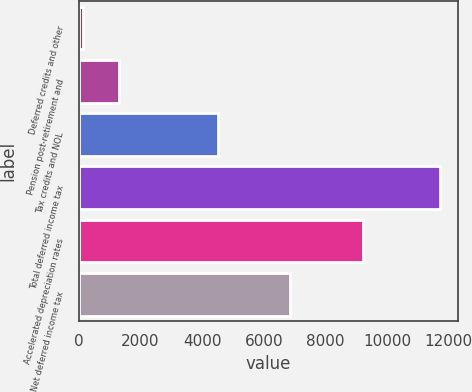<chart> <loc_0><loc_0><loc_500><loc_500><bar_chart><fcel>Deferred credits and other<fcel>Pension post-retirement and<fcel>Tax credits and NOL<fcel>Total deferred income tax<fcel>Accelerated depreciation rates<fcel>Net deferred income tax<nl><fcel>143<fcel>1301.2<fcel>4527<fcel>11725<fcel>9216<fcel>6843.4<nl></chart> 